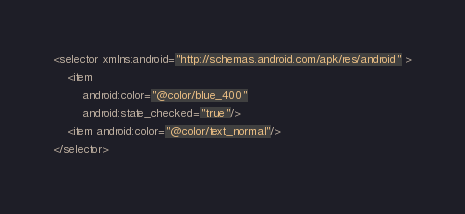<code> <loc_0><loc_0><loc_500><loc_500><_XML_><selector xmlns:android="http://schemas.android.com/apk/res/android" >
    <item
        android:color="@color/blue_400"
        android:state_checked="true"/>
    <item android:color="@color/text_normal"/>
</selector>
</code> 